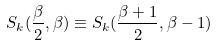Convert formula to latex. <formula><loc_0><loc_0><loc_500><loc_500>S _ { k } ( \frac { \beta } { 2 } , \beta ) \equiv S _ { k } ( \frac { \beta + 1 } { 2 } , \beta - 1 )</formula> 